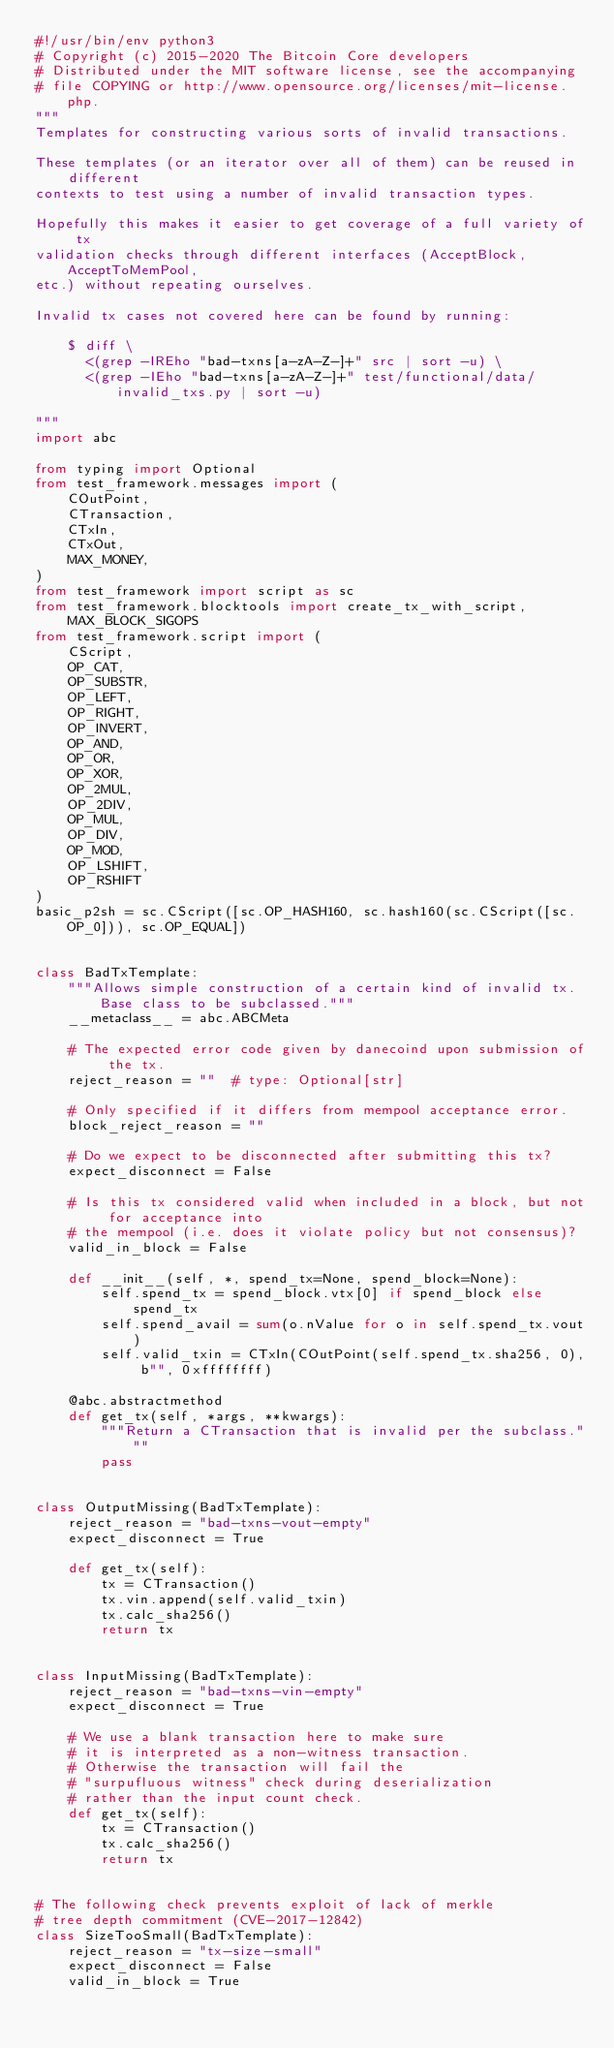<code> <loc_0><loc_0><loc_500><loc_500><_Python_>#!/usr/bin/env python3
# Copyright (c) 2015-2020 The Bitcoin Core developers
# Distributed under the MIT software license, see the accompanying
# file COPYING or http://www.opensource.org/licenses/mit-license.php.
"""
Templates for constructing various sorts of invalid transactions.

These templates (or an iterator over all of them) can be reused in different
contexts to test using a number of invalid transaction types.

Hopefully this makes it easier to get coverage of a full variety of tx
validation checks through different interfaces (AcceptBlock, AcceptToMemPool,
etc.) without repeating ourselves.

Invalid tx cases not covered here can be found by running:

    $ diff \
      <(grep -IREho "bad-txns[a-zA-Z-]+" src | sort -u) \
      <(grep -IEho "bad-txns[a-zA-Z-]+" test/functional/data/invalid_txs.py | sort -u)

"""
import abc

from typing import Optional
from test_framework.messages import (
    COutPoint,
    CTransaction,
    CTxIn,
    CTxOut,
    MAX_MONEY,
)
from test_framework import script as sc
from test_framework.blocktools import create_tx_with_script, MAX_BLOCK_SIGOPS
from test_framework.script import (
    CScript,
    OP_CAT,
    OP_SUBSTR,
    OP_LEFT,
    OP_RIGHT,
    OP_INVERT,
    OP_AND,
    OP_OR,
    OP_XOR,
    OP_2MUL,
    OP_2DIV,
    OP_MUL,
    OP_DIV,
    OP_MOD,
    OP_LSHIFT,
    OP_RSHIFT
)
basic_p2sh = sc.CScript([sc.OP_HASH160, sc.hash160(sc.CScript([sc.OP_0])), sc.OP_EQUAL])


class BadTxTemplate:
    """Allows simple construction of a certain kind of invalid tx. Base class to be subclassed."""
    __metaclass__ = abc.ABCMeta

    # The expected error code given by danecoind upon submission of the tx.
    reject_reason = ""  # type: Optional[str]

    # Only specified if it differs from mempool acceptance error.
    block_reject_reason = ""

    # Do we expect to be disconnected after submitting this tx?
    expect_disconnect = False

    # Is this tx considered valid when included in a block, but not for acceptance into
    # the mempool (i.e. does it violate policy but not consensus)?
    valid_in_block = False

    def __init__(self, *, spend_tx=None, spend_block=None):
        self.spend_tx = spend_block.vtx[0] if spend_block else spend_tx
        self.spend_avail = sum(o.nValue for o in self.spend_tx.vout)
        self.valid_txin = CTxIn(COutPoint(self.spend_tx.sha256, 0), b"", 0xffffffff)

    @abc.abstractmethod
    def get_tx(self, *args, **kwargs):
        """Return a CTransaction that is invalid per the subclass."""
        pass


class OutputMissing(BadTxTemplate):
    reject_reason = "bad-txns-vout-empty"
    expect_disconnect = True

    def get_tx(self):
        tx = CTransaction()
        tx.vin.append(self.valid_txin)
        tx.calc_sha256()
        return tx


class InputMissing(BadTxTemplate):
    reject_reason = "bad-txns-vin-empty"
    expect_disconnect = True

    # We use a blank transaction here to make sure
    # it is interpreted as a non-witness transaction.
    # Otherwise the transaction will fail the
    # "surpufluous witness" check during deserialization
    # rather than the input count check.
    def get_tx(self):
        tx = CTransaction()
        tx.calc_sha256()
        return tx


# The following check prevents exploit of lack of merkle
# tree depth commitment (CVE-2017-12842)
class SizeTooSmall(BadTxTemplate):
    reject_reason = "tx-size-small"
    expect_disconnect = False
    valid_in_block = True
</code> 